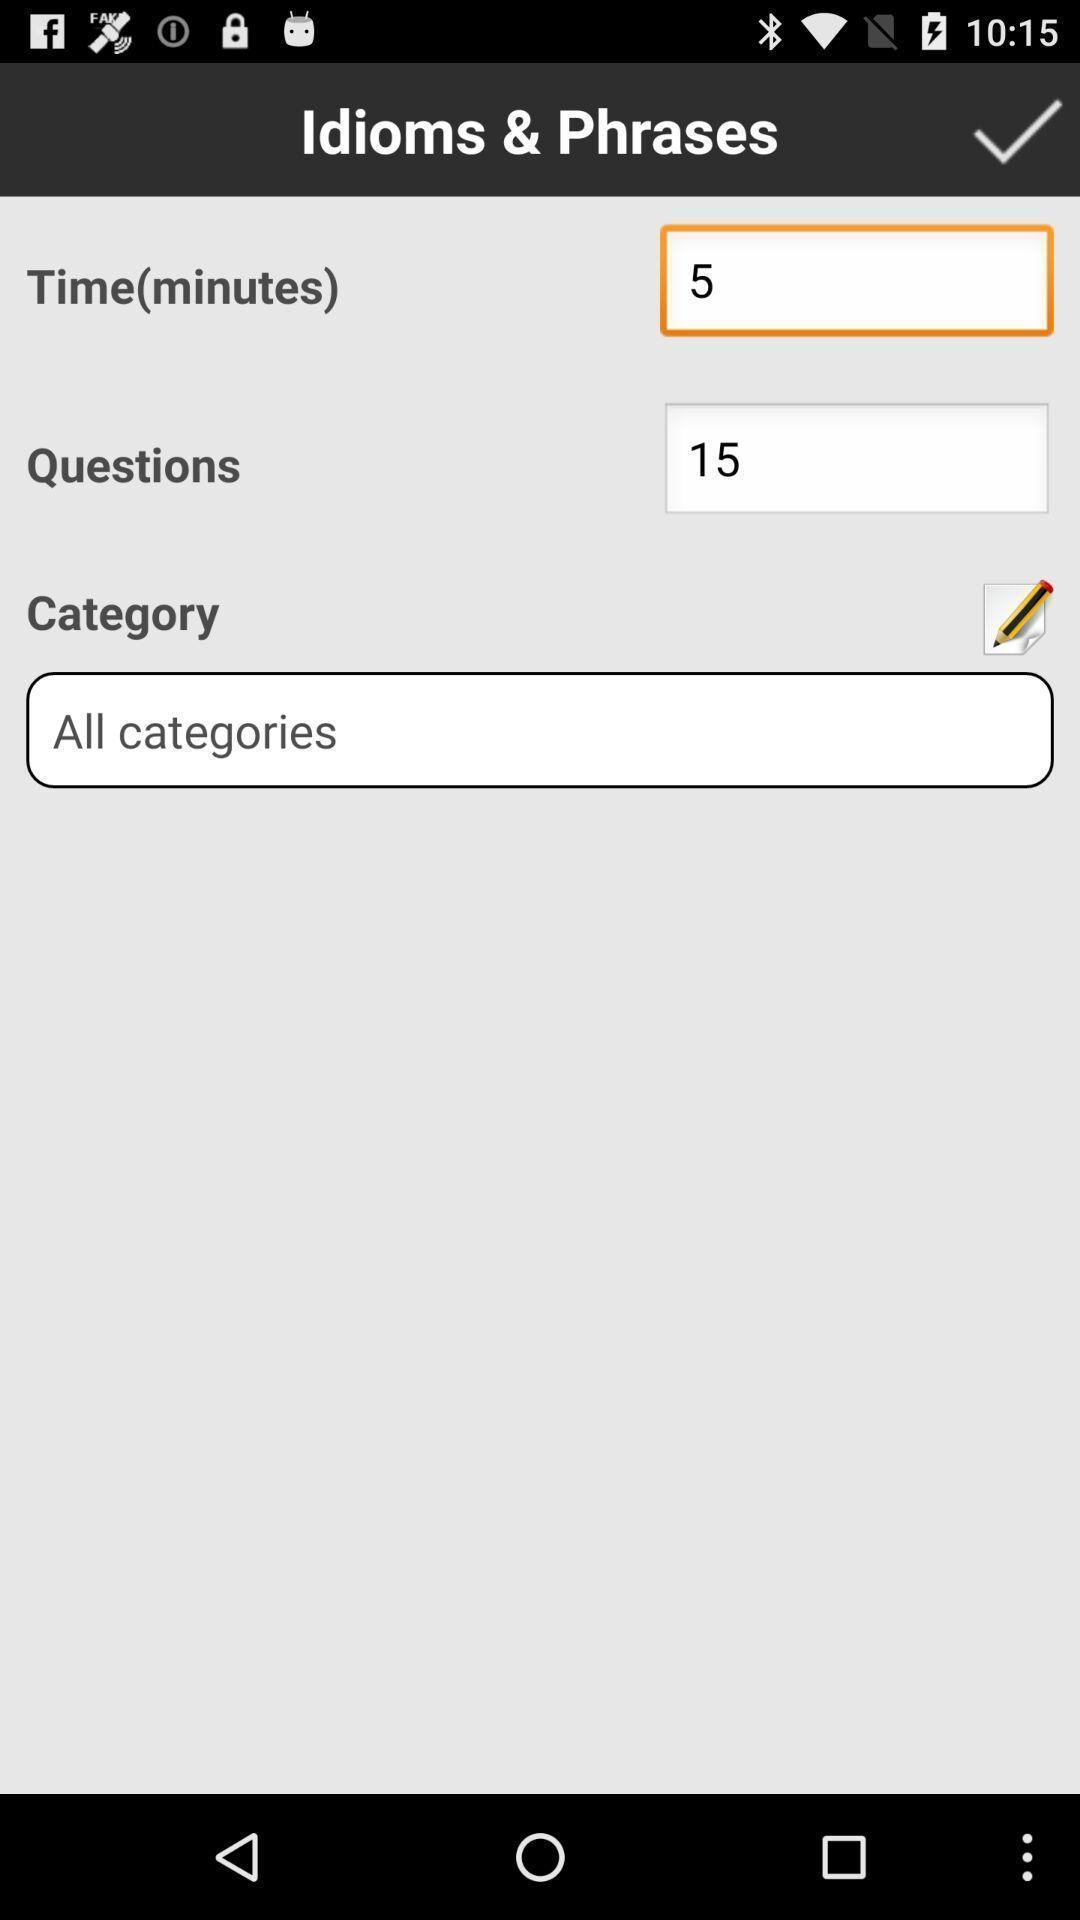Provide a description of this screenshot. Page with time and questions. 